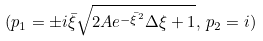Convert formula to latex. <formula><loc_0><loc_0><loc_500><loc_500>( p _ { 1 } = \pm i \bar { \xi } \sqrt { 2 A e ^ { - \bar { \xi } ^ { 2 } } \Delta \xi + 1 } , \, p _ { 2 } = i )</formula> 